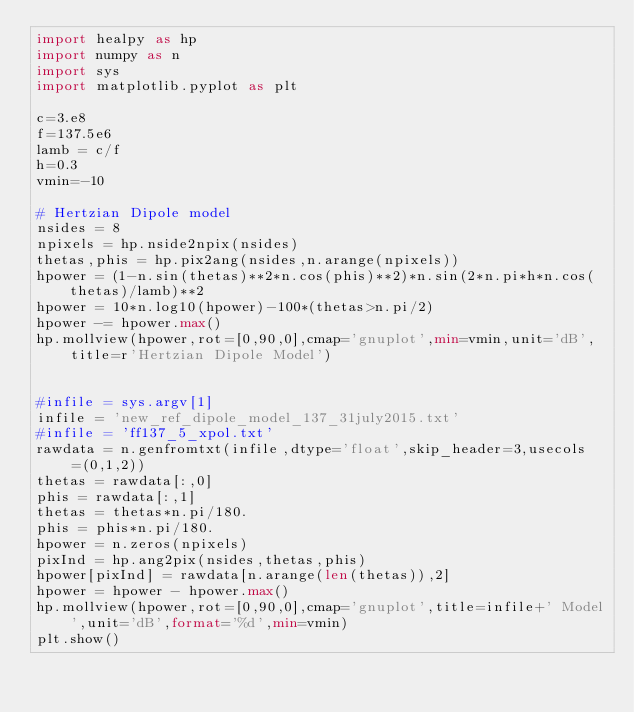<code> <loc_0><loc_0><loc_500><loc_500><_Python_>import healpy as hp
import numpy as n
import sys
import matplotlib.pyplot as plt

c=3.e8
f=137.5e6
lamb = c/f
h=0.3
vmin=-10

# Hertzian Dipole model
nsides = 8
npixels = hp.nside2npix(nsides)
thetas,phis = hp.pix2ang(nsides,n.arange(npixels))
hpower = (1-n.sin(thetas)**2*n.cos(phis)**2)*n.sin(2*n.pi*h*n.cos(thetas)/lamb)**2
hpower = 10*n.log10(hpower)-100*(thetas>n.pi/2)
hpower -= hpower.max()
hp.mollview(hpower,rot=[0,90,0],cmap='gnuplot',min=vmin,unit='dB',title=r'Hertzian Dipole Model')


#infile = sys.argv[1]
infile = 'new_ref_dipole_model_137_31july2015.txt'
#infile = 'ff137_5_xpol.txt'
rawdata = n.genfromtxt(infile,dtype='float',skip_header=3,usecols=(0,1,2))
thetas = rawdata[:,0]
phis = rawdata[:,1]
thetas = thetas*n.pi/180.
phis = phis*n.pi/180.
hpower = n.zeros(npixels)
pixInd = hp.ang2pix(nsides,thetas,phis)
hpower[pixInd] = rawdata[n.arange(len(thetas)),2]
hpower = hpower - hpower.max()
hp.mollview(hpower,rot=[0,90,0],cmap='gnuplot',title=infile+' Model',unit='dB',format='%d',min=vmin)
plt.show()
</code> 